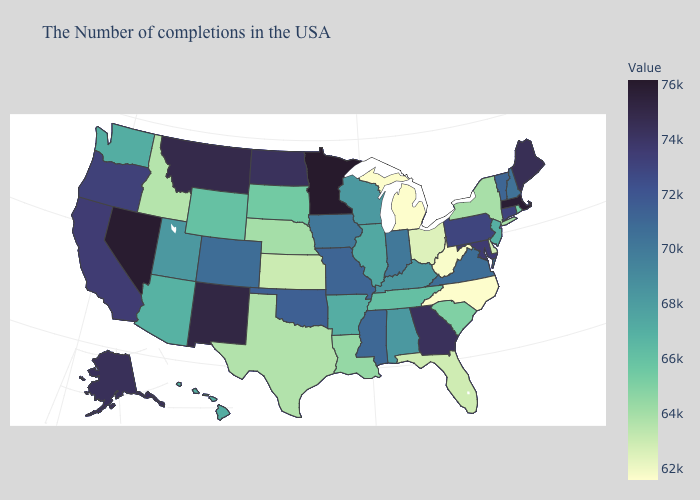Among the states that border Florida , does Georgia have the highest value?
Give a very brief answer. Yes. Does Arizona have the highest value in the West?
Write a very short answer. No. Does the map have missing data?
Write a very short answer. No. Which states hav the highest value in the MidWest?
Short answer required. Minnesota. 